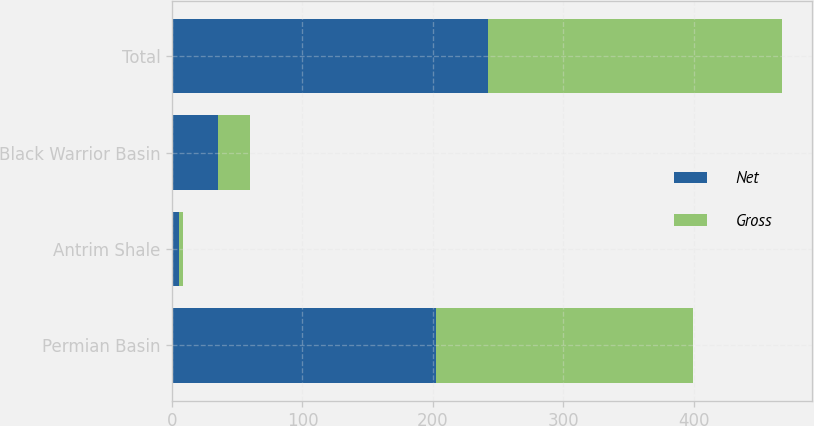Convert chart. <chart><loc_0><loc_0><loc_500><loc_500><stacked_bar_chart><ecel><fcel>Permian Basin<fcel>Antrim Shale<fcel>Black Warrior Basin<fcel>Total<nl><fcel>Net<fcel>202<fcel>5<fcel>35<fcel>242<nl><fcel>Gross<fcel>197.2<fcel>3.7<fcel>24.5<fcel>225.4<nl></chart> 